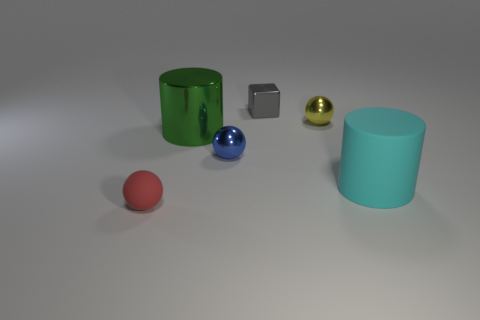What color is the big cylinder that is made of the same material as the small gray block?
Give a very brief answer. Green. What number of small things are yellow objects or matte cylinders?
Your response must be concise. 1. How many matte things are on the right side of the gray object?
Offer a very short reply. 1. What color is the other shiny object that is the same shape as the yellow object?
Offer a terse response. Blue. How many rubber things are small red cylinders or tiny red spheres?
Your answer should be compact. 1. There is a large object behind the matte object that is to the right of the large green object; is there a tiny metallic object in front of it?
Ensure brevity in your answer.  Yes. What is the color of the cube?
Your answer should be compact. Gray. Is the shape of the matte object that is to the right of the block the same as  the big green object?
Keep it short and to the point. Yes. How many things are either gray things or big cylinders on the left side of the big cyan matte cylinder?
Offer a terse response. 2. Is the ball behind the green cylinder made of the same material as the cyan cylinder?
Make the answer very short. No. 